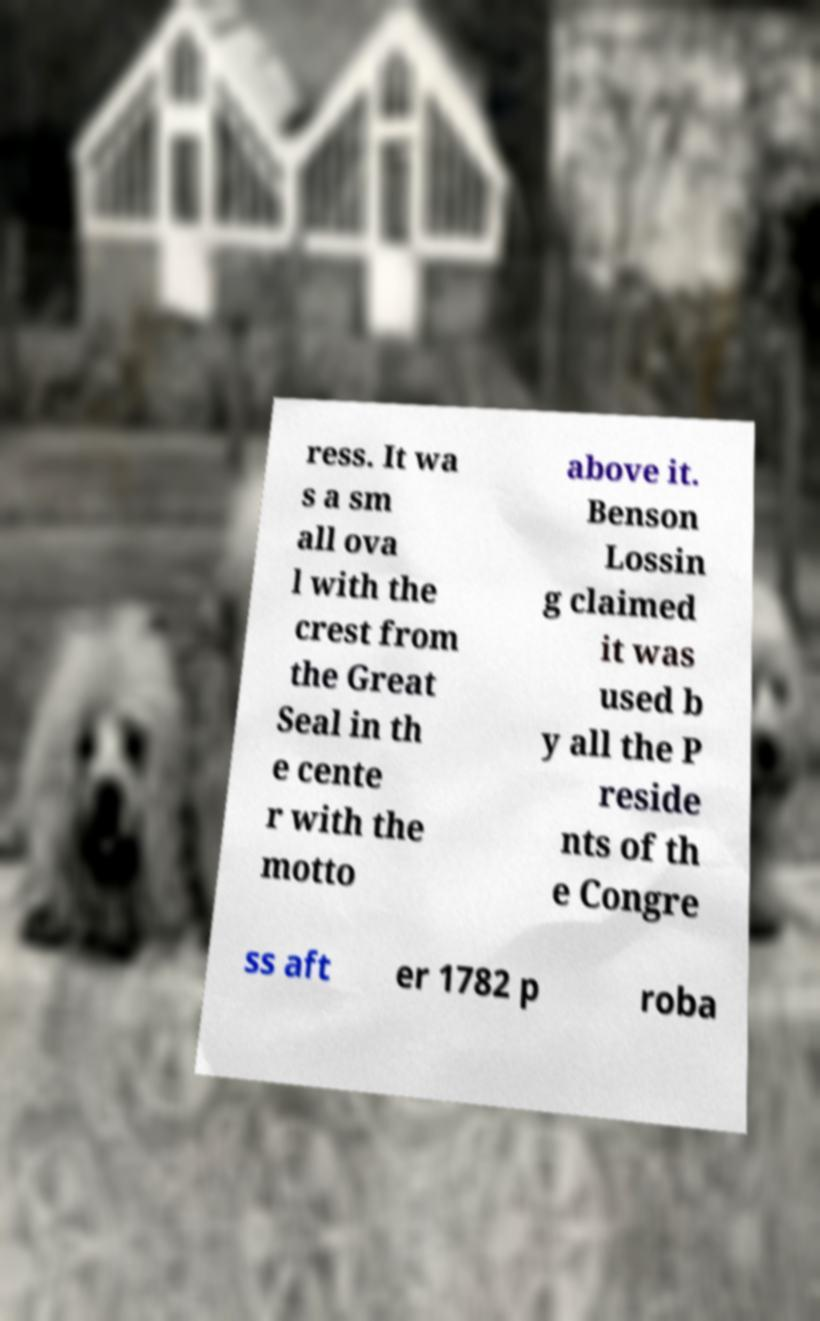For documentation purposes, I need the text within this image transcribed. Could you provide that? ress. It wa s a sm all ova l with the crest from the Great Seal in th e cente r with the motto above it. Benson Lossin g claimed it was used b y all the P reside nts of th e Congre ss aft er 1782 p roba 